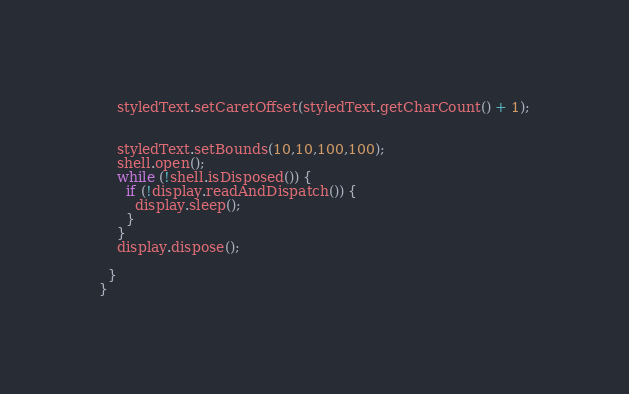<code> <loc_0><loc_0><loc_500><loc_500><_Java_>
    styledText.setCaretOffset(styledText.getCharCount() + 1);
    
    
    styledText.setBounds(10,10,100,100);
    shell.open();
    while (!shell.isDisposed()) {
      if (!display.readAndDispatch()) {
        display.sleep();
      }
    }
    display.dispose();

  }
}
</code> 